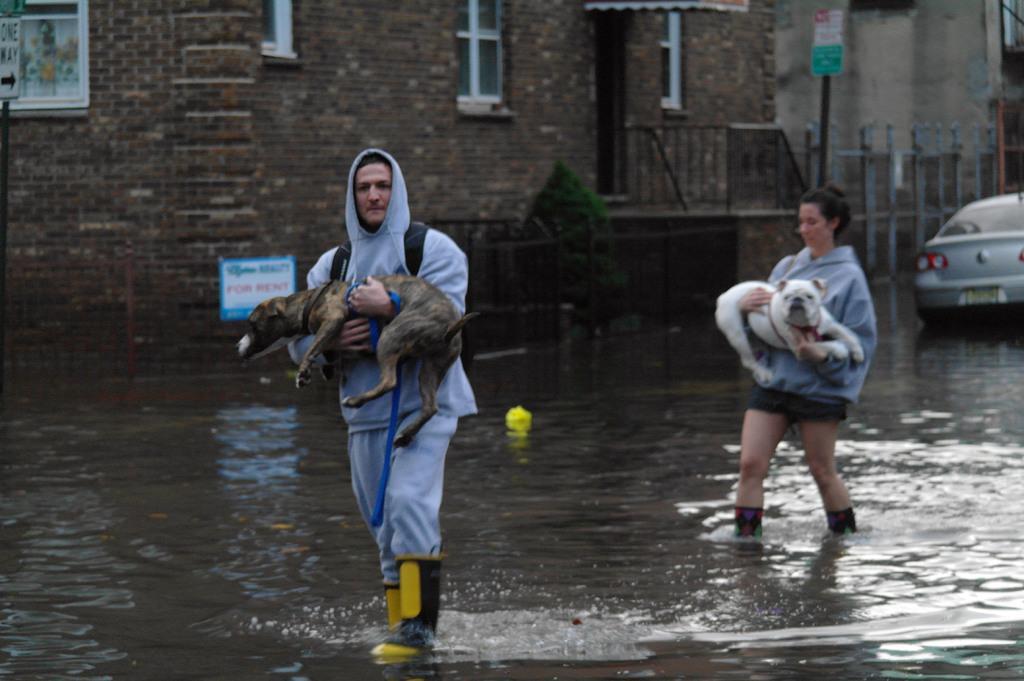Can you describe this image briefly? This is completely an outdoor picture and the road is full of water. We can see two persons walking on the road by holding dogs. On the background we can see a building and there is a car near to to building. This is a board. 